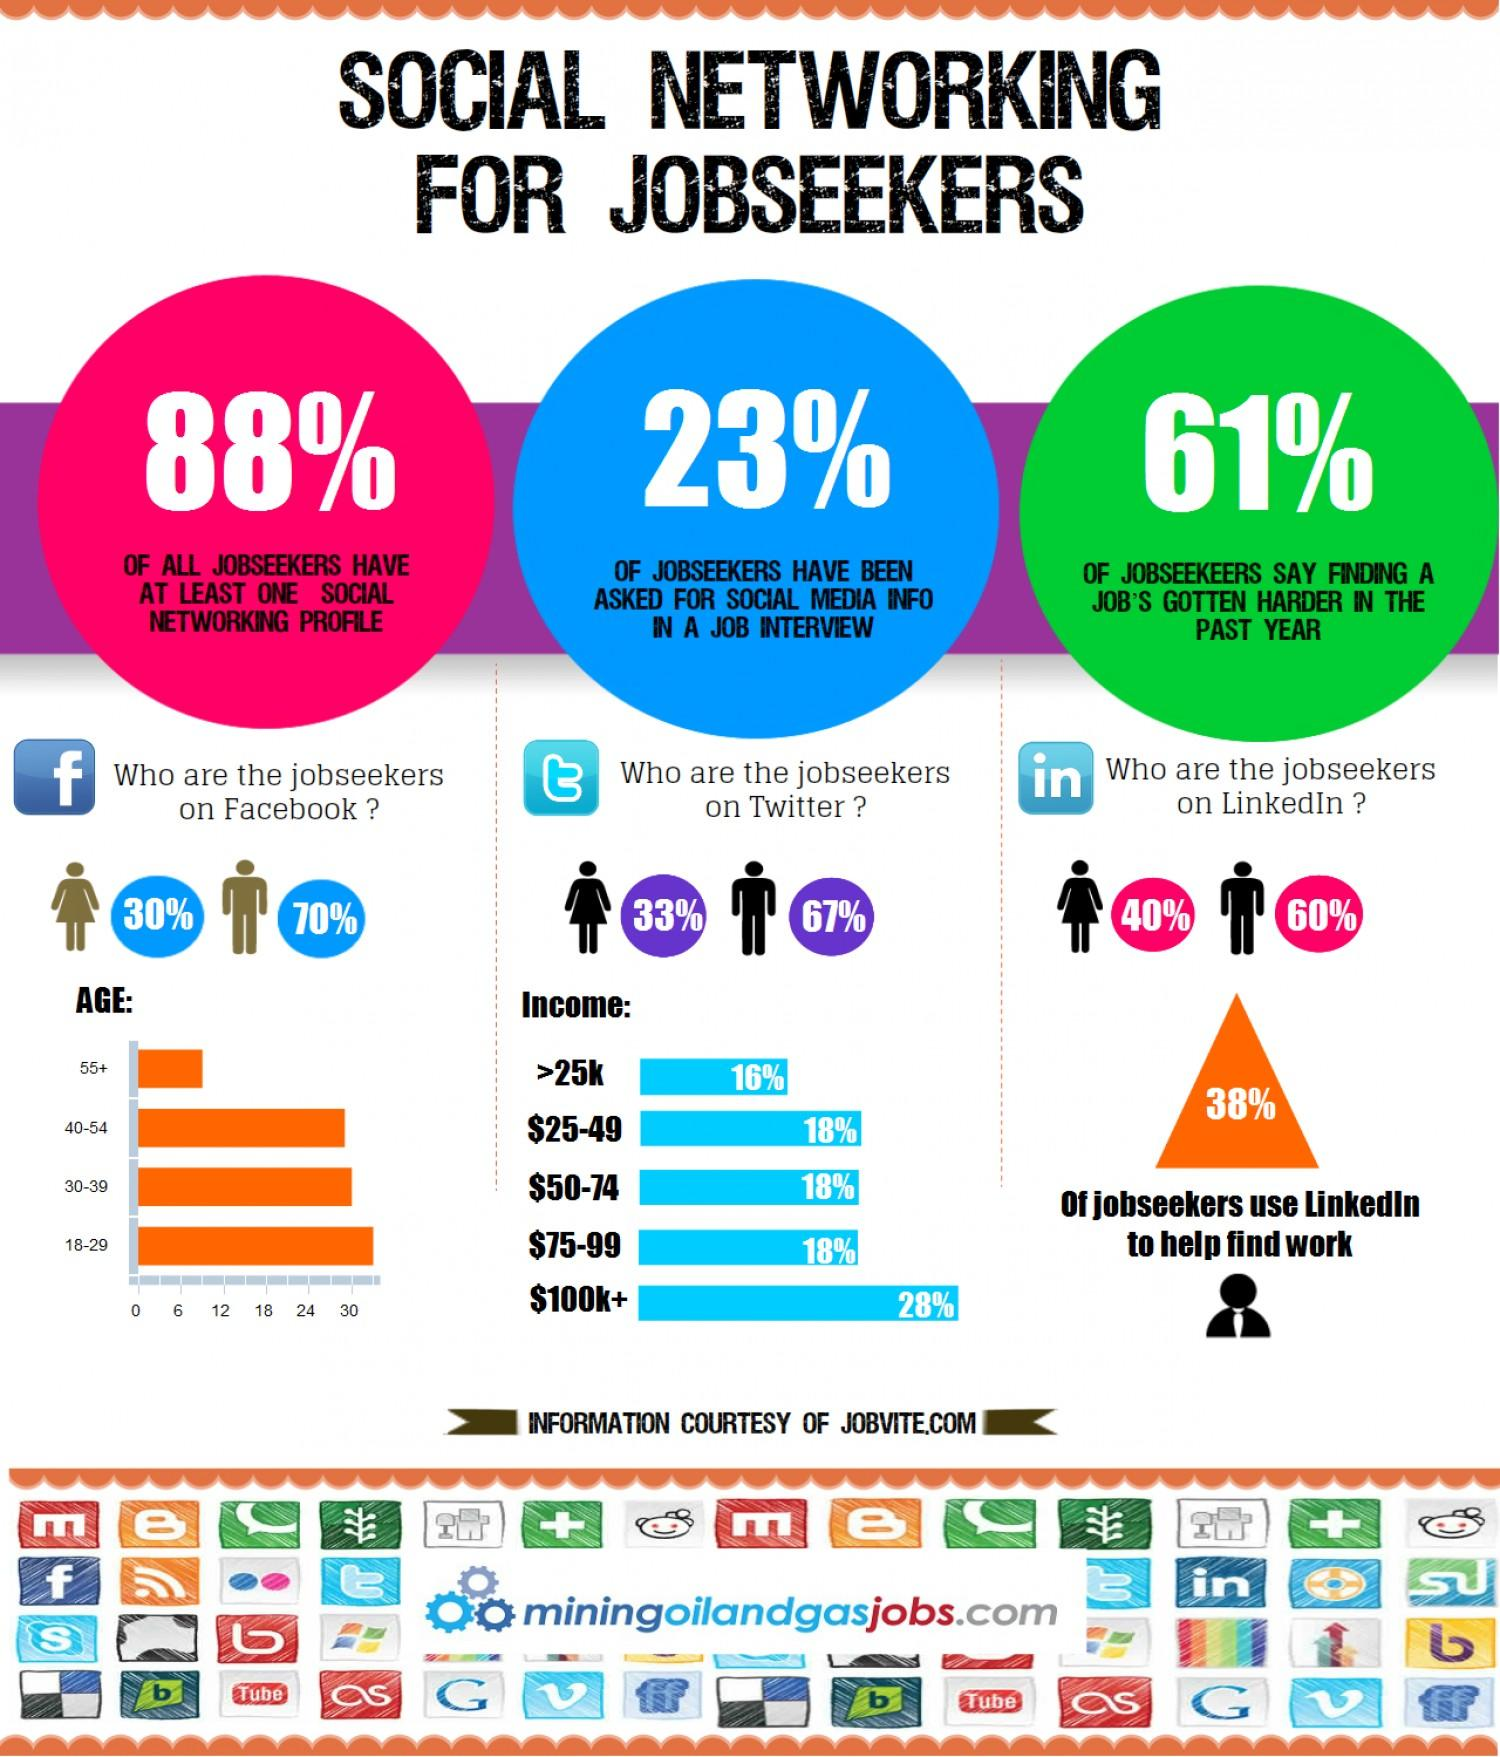Outline some significant characteristics in this image. According to a recent survey, only 12% of jobseekers do not have a social networking profile. According to data, a majority of jobseekers, approximately 62%, do not use LinkedIn to find work. According to data, the age group that utilizes Facebook the most for job searching is 18-29 year olds. According to a recent survey, approximately 30% of females are actively seeking employment on Facebook. Approximately 36% of individuals have incomes that fall within the range of $25,000 to $74,000. 